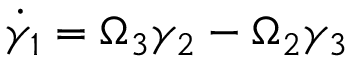Convert formula to latex. <formula><loc_0><loc_0><loc_500><loc_500>\dot { \gamma } _ { 1 } = \Omega _ { 3 } \gamma _ { 2 } - \Omega _ { 2 } \gamma _ { 3 }</formula> 